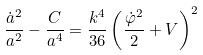<formula> <loc_0><loc_0><loc_500><loc_500>\frac { \dot { a } ^ { 2 } } { a ^ { 2 } } - \frac { C } { a ^ { 4 } } = \frac { k ^ { 4 } } { 3 6 } \left ( \frac { \dot { \varphi } ^ { 2 } } { 2 } + V \right ) ^ { 2 }</formula> 